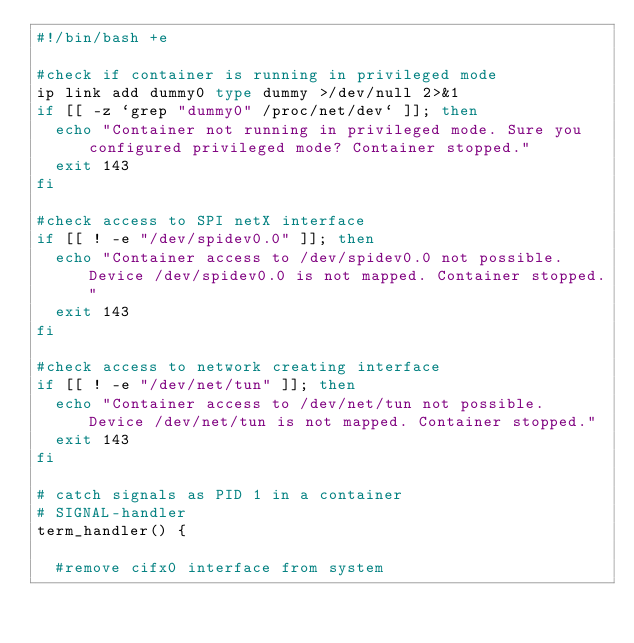Convert code to text. <code><loc_0><loc_0><loc_500><loc_500><_Bash_>#!/bin/bash +e

#check if container is running in privileged mode
ip link add dummy0 type dummy >/dev/null 2>&1
if [[ -z `grep "dummy0" /proc/net/dev` ]]; then
  echo "Container not running in privileged mode. Sure you configured privileged mode? Container stopped."
  exit 143
fi

#check access to SPI netX interface
if [[ ! -e "/dev/spidev0.0" ]]; then
  echo "Container access to /dev/spidev0.0 not possible. Device /dev/spidev0.0 is not mapped. Container stopped."
  exit 143
fi

#check access to network creating interface
if [[ ! -e "/dev/net/tun" ]]; then
  echo "Container access to /dev/net/tun not possible. Device /dev/net/tun is not mapped. Container stopped."
  exit 143
fi

# catch signals as PID 1 in a container
# SIGNAL-handler
term_handler() {

  #remove cifx0 interface from system</code> 